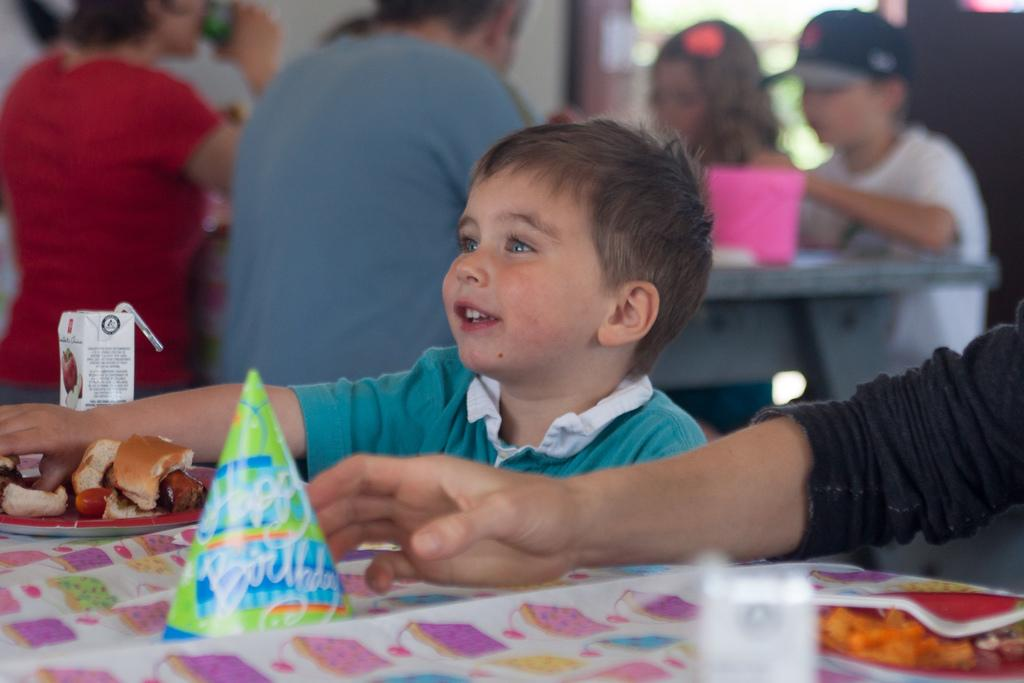What is the main subject of the image? There is a kid in the image. What can be seen on the table in the image? There are objects on the table in the image. Can you describe the background of the image? There are people visible in the background of the image. What type of stick is the kid using to show off their oranges in the image? There is no stick or oranges present in the image. 